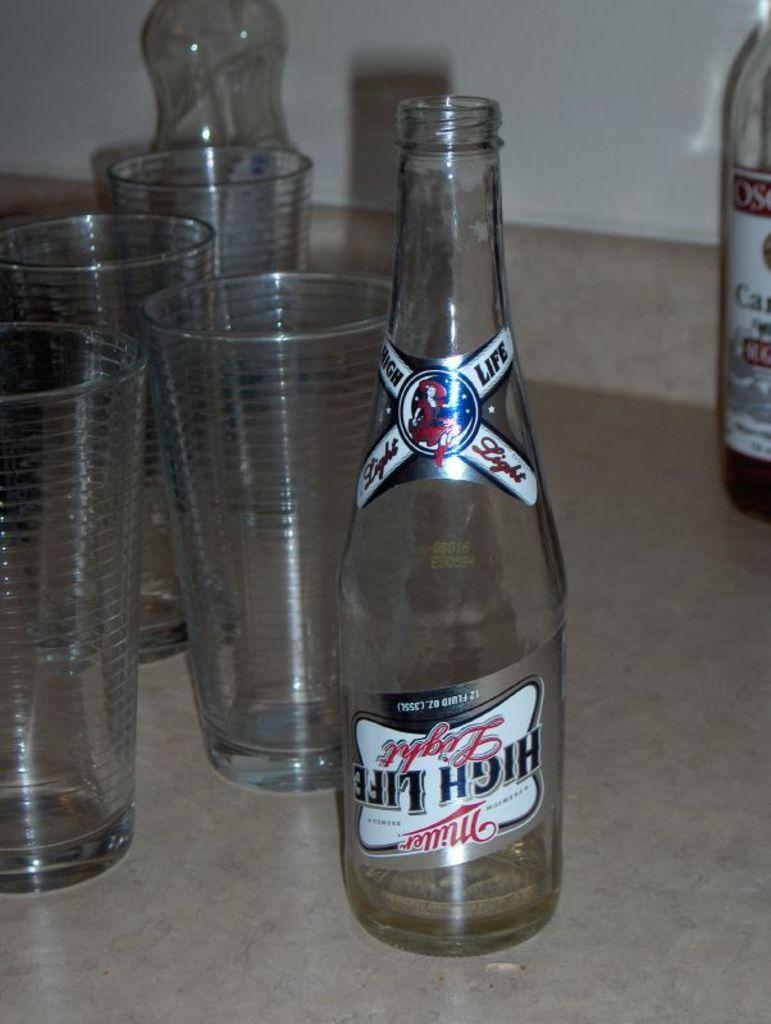Provide a one-sentence caption for the provided image. An empty bottle of Miller High Life sits on a table next to some empty glasses. 